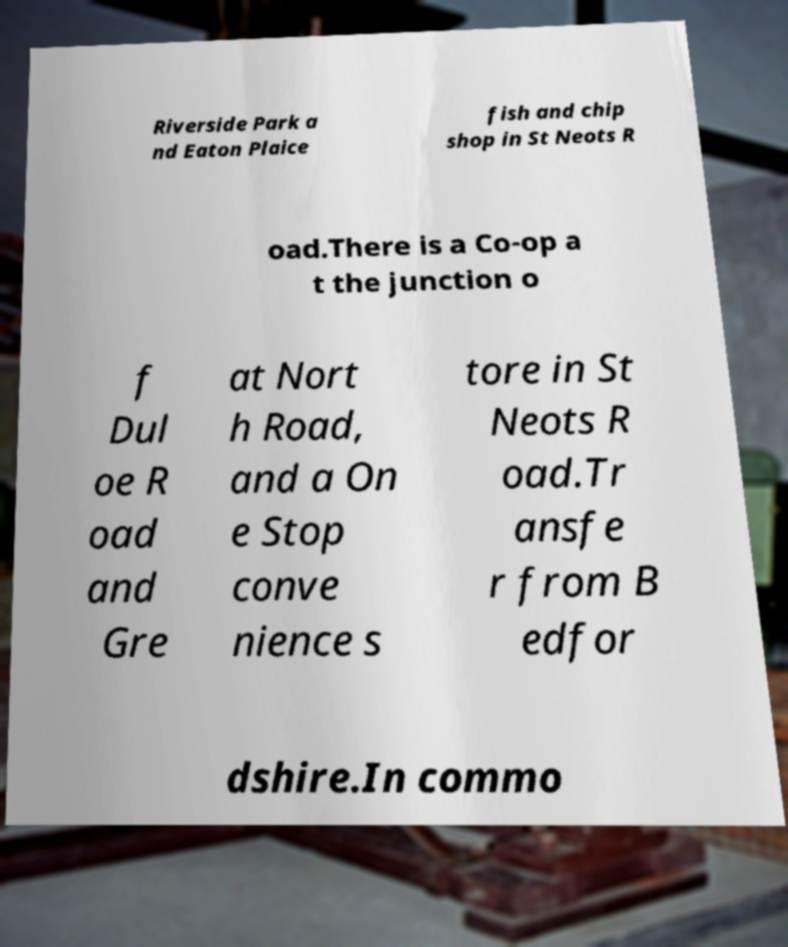There's text embedded in this image that I need extracted. Can you transcribe it verbatim? Riverside Park a nd Eaton Plaice fish and chip shop in St Neots R oad.There is a Co-op a t the junction o f Dul oe R oad and Gre at Nort h Road, and a On e Stop conve nience s tore in St Neots R oad.Tr ansfe r from B edfor dshire.In commo 